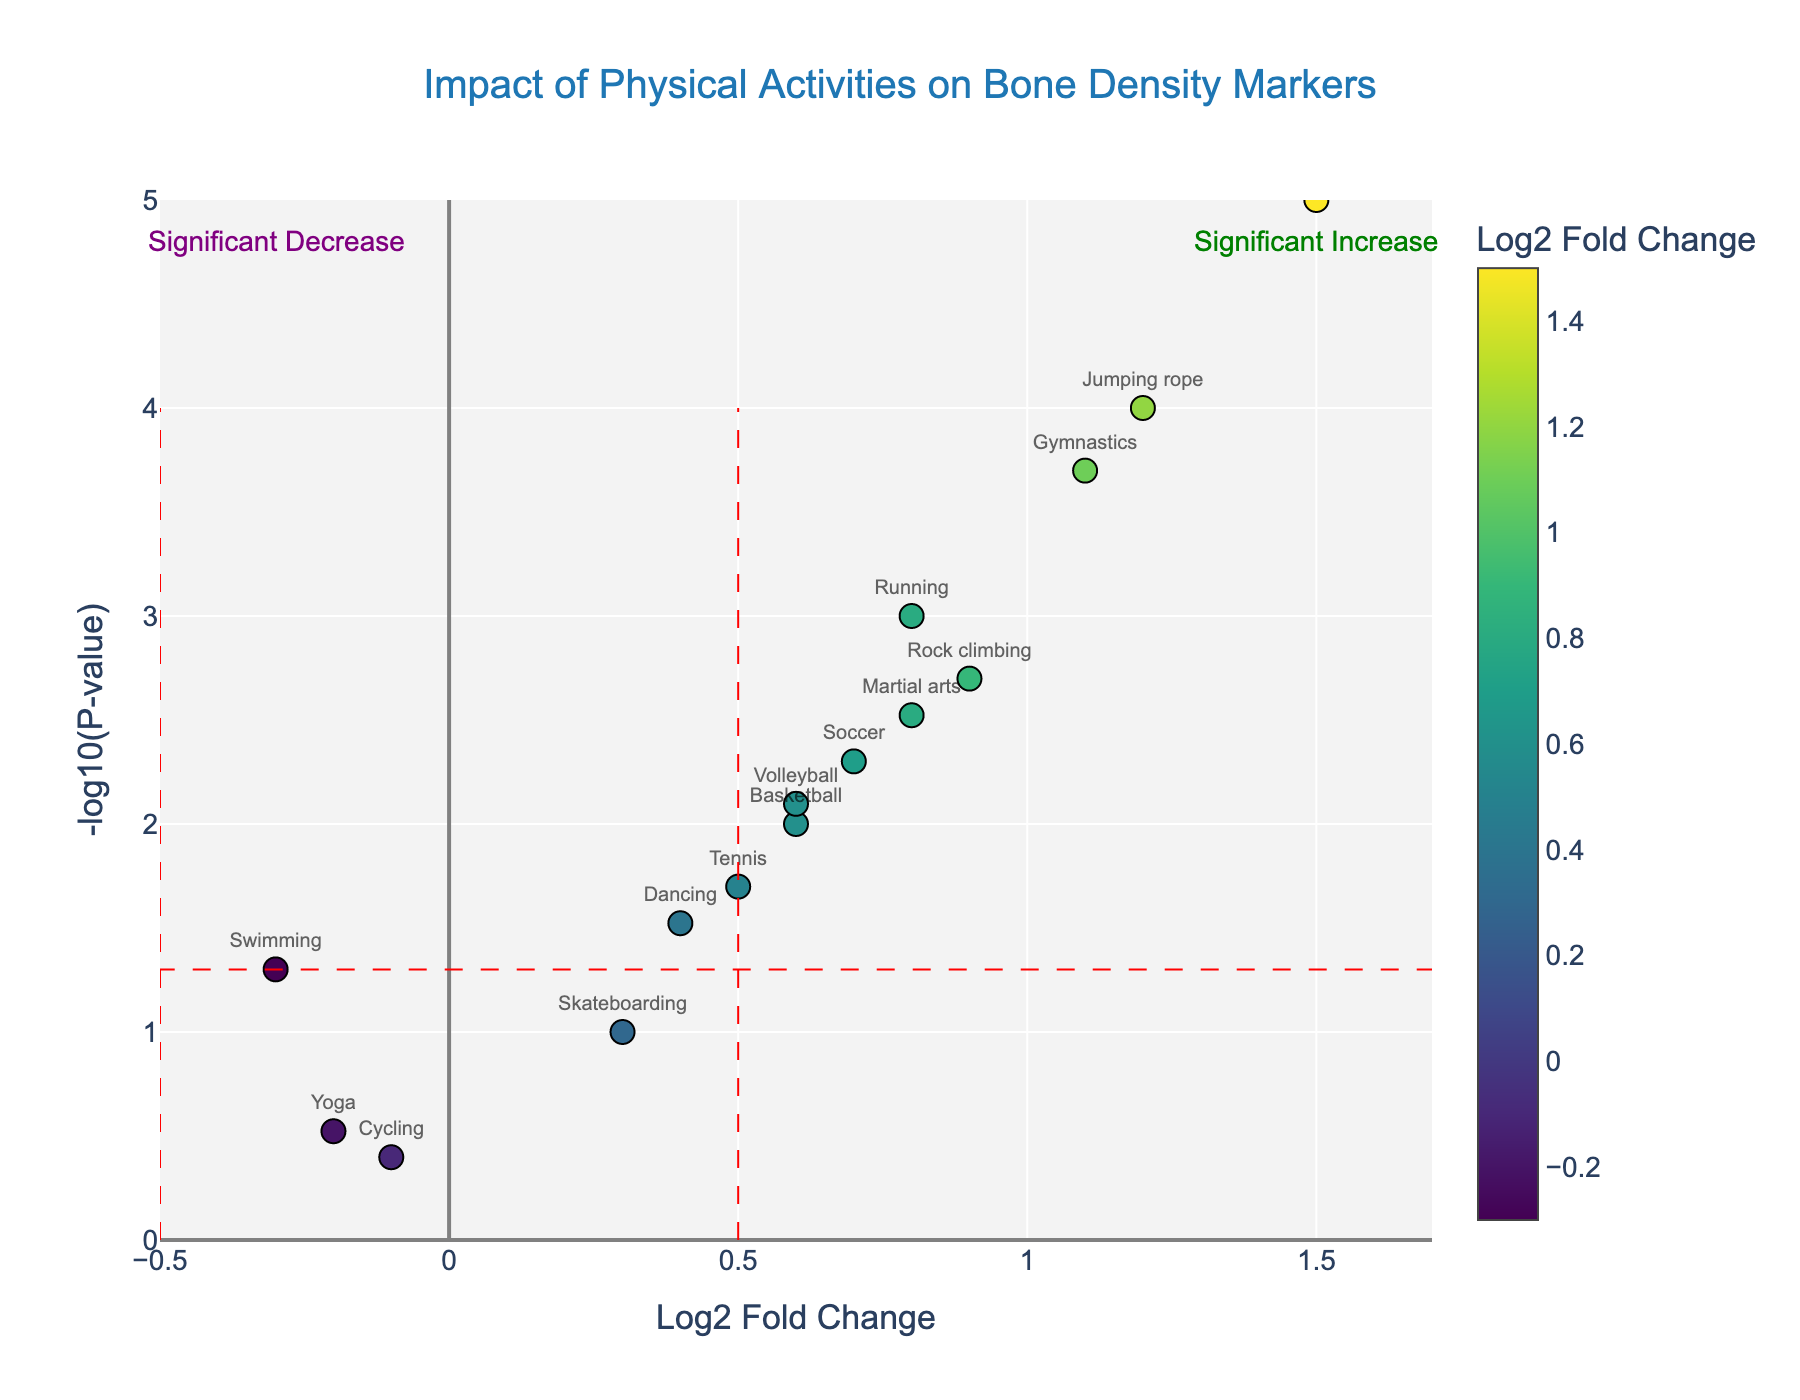What does the title of the plot indicate? The title of the plot, "Impact of Physical Activities on Bone Density Markers", indicates that the plot shows how various physical activities affect certain markers related to bone density.
Answer: Impact of Physical Activities on Bone Density Markers How many physical activities are analyzed in the plot? By counting the number of data points (markers), we see that there are 15 physical activities analyzed in the plot.
Answer: 15 Which activity shows the highest positive impact on bone density markers? The highest positive impact on bone density markers is represented by the data point with the highest log2 fold change value. Weightlifting has the highest log2 fold change (1.5).
Answer: Weightlifting Which activity shows the lowest p-value? The lowest p-value corresponds to the highest -log10(pValue). Jumping rope has the highest -log10(pValue) (>4), indicating the lowest p-value.
Answer: Jumping rope What does a significant increase or decrease in bone density markers mean as indicated by the plot annotations? A significant increase in bone density markers is indicated by a higher log2 fold change and lower p-value (above the horizontal threshold line and to the right of the vertical threshold line). A significant decrease is indicated by a lower log2 fold change and lower p-value (above the horizontal threshold line and to the left of the vertical threshold line).
Answer: Significant increase/decrease indicators Which activities fall below the significance threshold in terms of p-value? Data points below the horizontal red dashed line represent activities with p-values greater than 0.05. Cycling and Yoga fall below this threshold.
Answer: Cycling and Yoga Between Soccer and Volleyball, which one has a greater impact on bone density markers? Comparing the log2 fold change of Soccer (0.7) and Volleyball (0.6), Soccer has a slightly greater impact on bone density markers.
Answer: Soccer Identify an activity that leads to a decrease in bone density markers and is also statistically significant. Activities with a negative log2 fold change and p-value < 0.05 (above the horizontal red dashed line). Swimming (log2 Fold Change of -0.3, p-value of 0.05) shows a decrease but is right at the threshold. However, it is the closest to meeting the criteria.
Answer: Swimming 